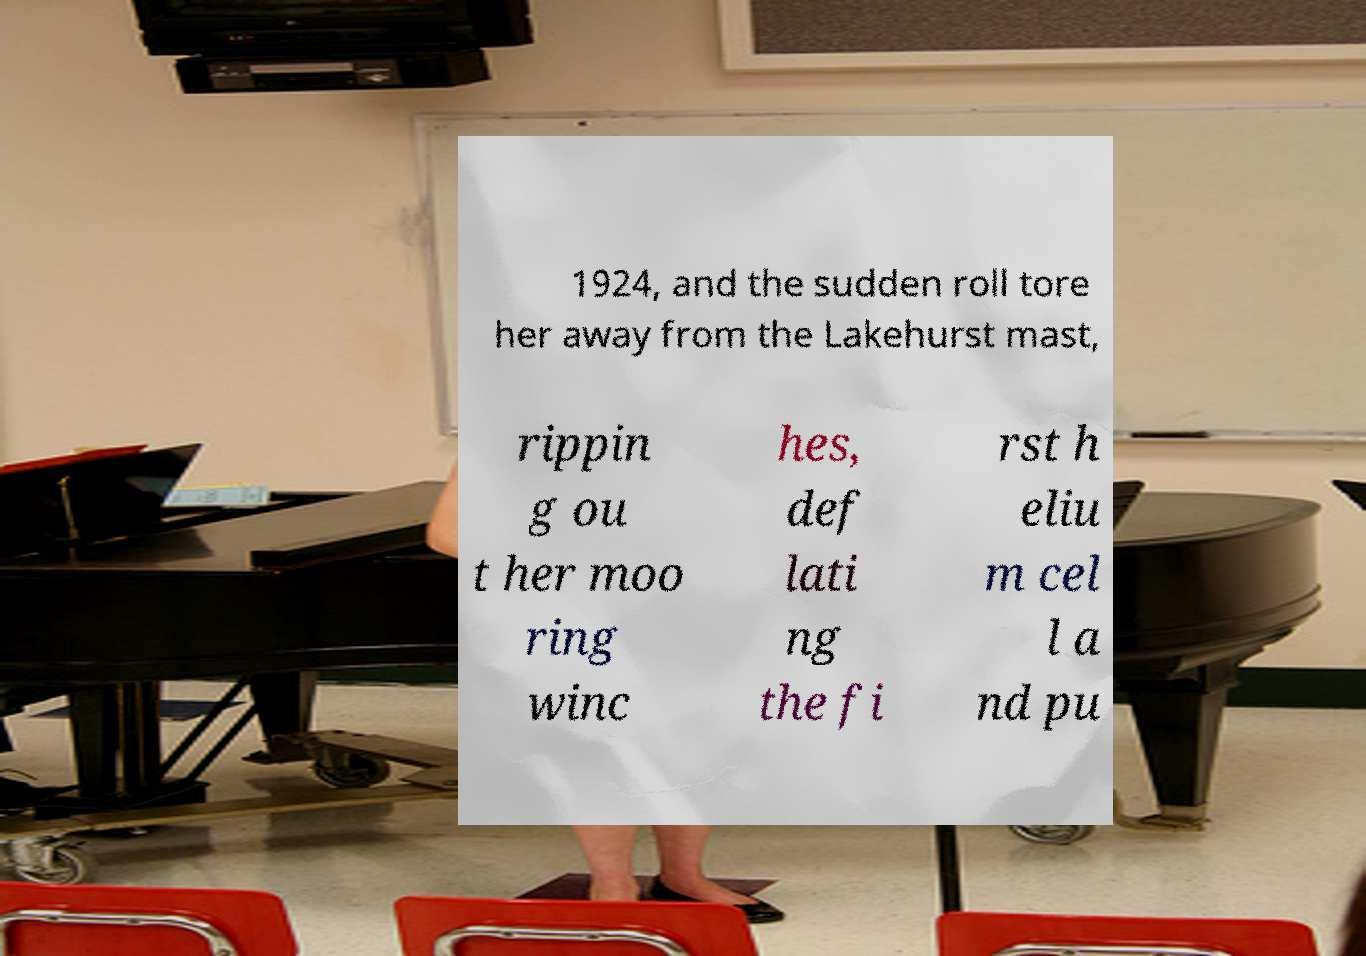For documentation purposes, I need the text within this image transcribed. Could you provide that? 1924, and the sudden roll tore her away from the Lakehurst mast, rippin g ou t her moo ring winc hes, def lati ng the fi rst h eliu m cel l a nd pu 